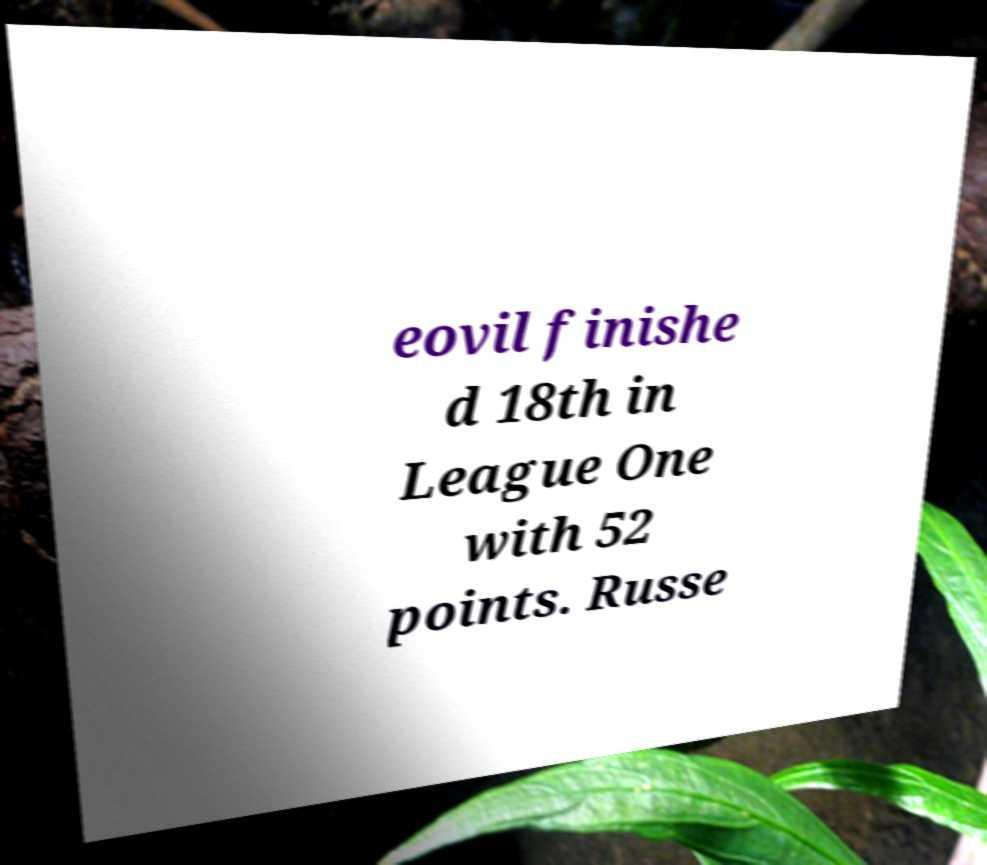There's text embedded in this image that I need extracted. Can you transcribe it verbatim? eovil finishe d 18th in League One with 52 points. Russe 